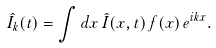<formula> <loc_0><loc_0><loc_500><loc_500>\hat { I } _ { k } ( t ) = \int d x \, \hat { I } ( x , t ) \, f ( x ) \, e ^ { i k x } .</formula> 